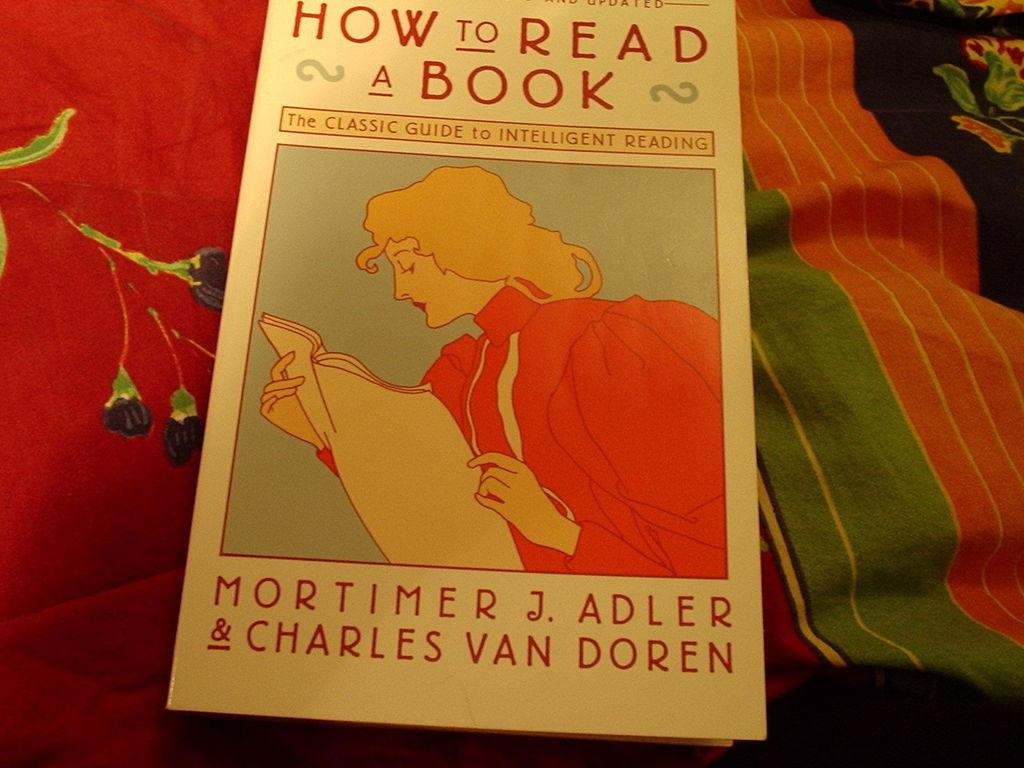Provide a one-sentence caption for the provided image. A guide of how to read is on top of a couple of blankets. 